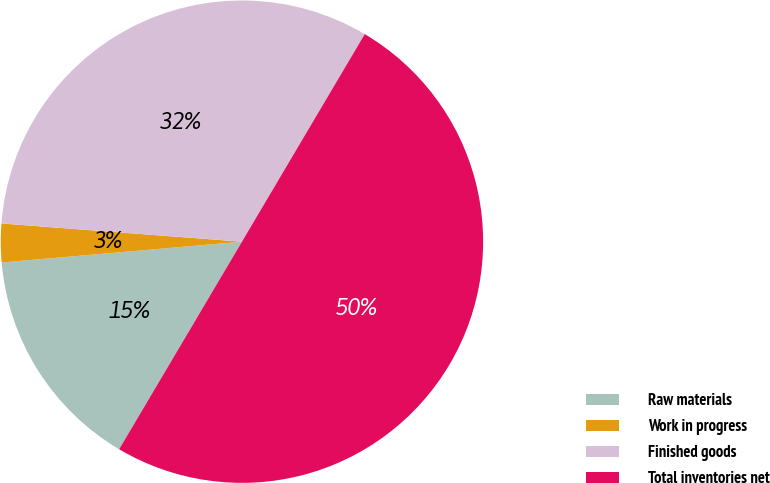Convert chart to OTSL. <chart><loc_0><loc_0><loc_500><loc_500><pie_chart><fcel>Raw materials<fcel>Work in progress<fcel>Finished goods<fcel>Total inventories net<nl><fcel>15.12%<fcel>2.58%<fcel>32.3%<fcel>50.0%<nl></chart> 